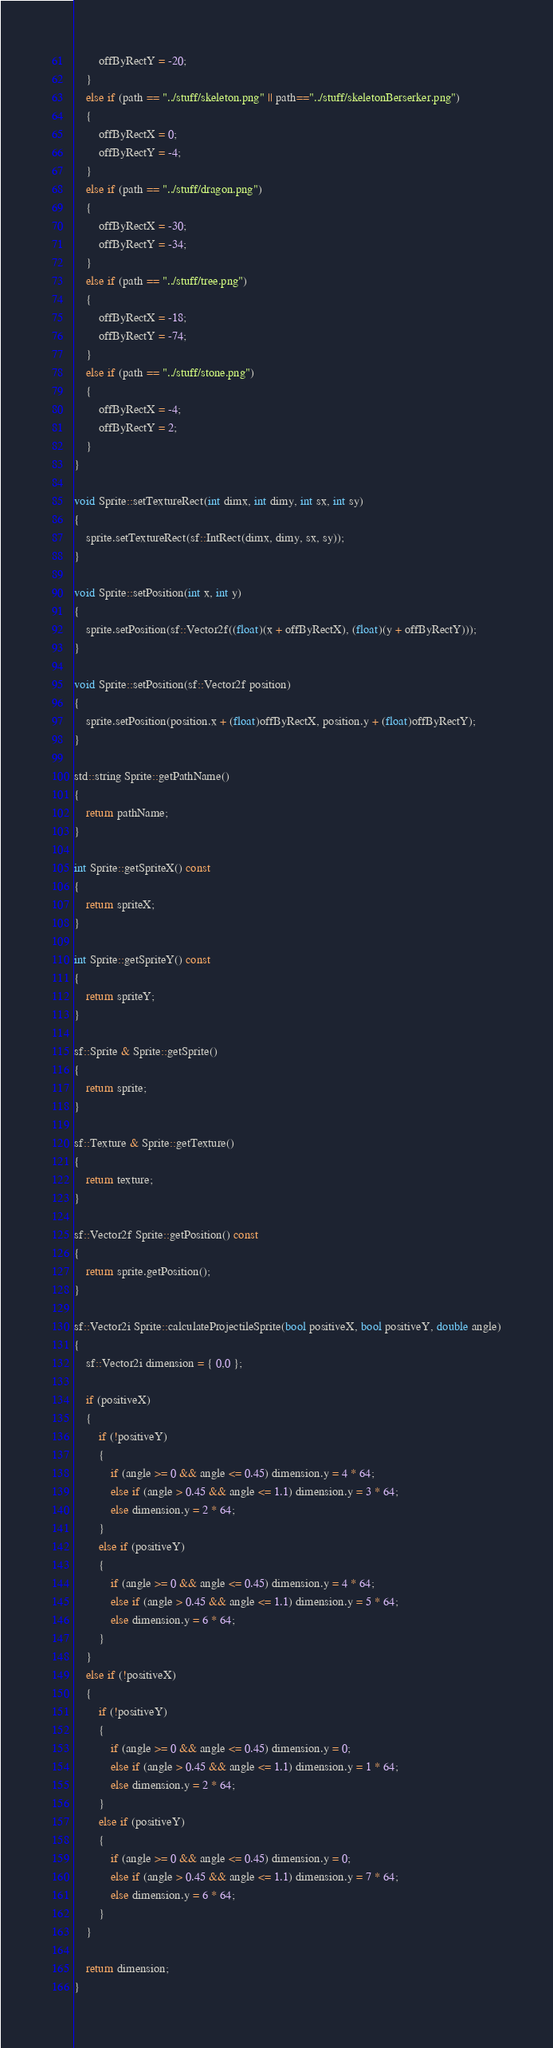Convert code to text. <code><loc_0><loc_0><loc_500><loc_500><_C++_>		offByRectY = -20;
	}
	else if (path == "../stuff/skeleton.png" || path=="../stuff/skeletonBerserker.png")
	{
		offByRectX = 0;
		offByRectY = -4;
	}
	else if (path == "../stuff/dragon.png")
	{
		offByRectX = -30;
		offByRectY = -34;
	}
	else if (path == "../stuff/tree.png")
	{
		offByRectX = -18;
		offByRectY = -74;
	}
	else if (path == "../stuff/stone.png")
	{
		offByRectX = -4;
		offByRectY = 2;
	}
}

void Sprite::setTextureRect(int dimx, int dimy, int sx, int sy)
{
	sprite.setTextureRect(sf::IntRect(dimx, dimy, sx, sy));
}

void Sprite::setPosition(int x, int y)
{
	sprite.setPosition(sf::Vector2f((float)(x + offByRectX), (float)(y + offByRectY)));
}

void Sprite::setPosition(sf::Vector2f position)
{
	sprite.setPosition(position.x + (float)offByRectX, position.y + (float)offByRectY);
}

std::string Sprite::getPathName()
{
	return pathName;
}

int Sprite::getSpriteX() const
{
	return spriteX;
}

int Sprite::getSpriteY() const
{
	return spriteY;
}

sf::Sprite & Sprite::getSprite()
{
	return sprite;
}

sf::Texture & Sprite::getTexture()
{
	return texture;
}

sf::Vector2f Sprite::getPosition() const
{
	return sprite.getPosition();
}

sf::Vector2i Sprite::calculateProjectileSprite(bool positiveX, bool positiveY, double angle)
{
	sf::Vector2i dimension = { 0,0 };

	if (positiveX)
	{
		if (!positiveY)
		{
			if (angle >= 0 && angle <= 0.45) dimension.y = 4 * 64;
			else if (angle > 0.45 && angle <= 1.1) dimension.y = 3 * 64;
			else dimension.y = 2 * 64;
		}
		else if (positiveY)
		{
			if (angle >= 0 && angle <= 0.45) dimension.y = 4 * 64;
			else if (angle > 0.45 && angle <= 1.1) dimension.y = 5 * 64;
			else dimension.y = 6 * 64;
		}
	}
	else if (!positiveX)
	{
		if (!positiveY)
		{
			if (angle >= 0 && angle <= 0.45) dimension.y = 0;
			else if (angle > 0.45 && angle <= 1.1) dimension.y = 1 * 64;
			else dimension.y = 2 * 64;
		}
		else if (positiveY)
		{
			if (angle >= 0 && angle <= 0.45) dimension.y = 0;
			else if (angle > 0.45 && angle <= 1.1) dimension.y = 7 * 64;
			else dimension.y = 6 * 64;
		}
	}

	return dimension;
}

</code> 